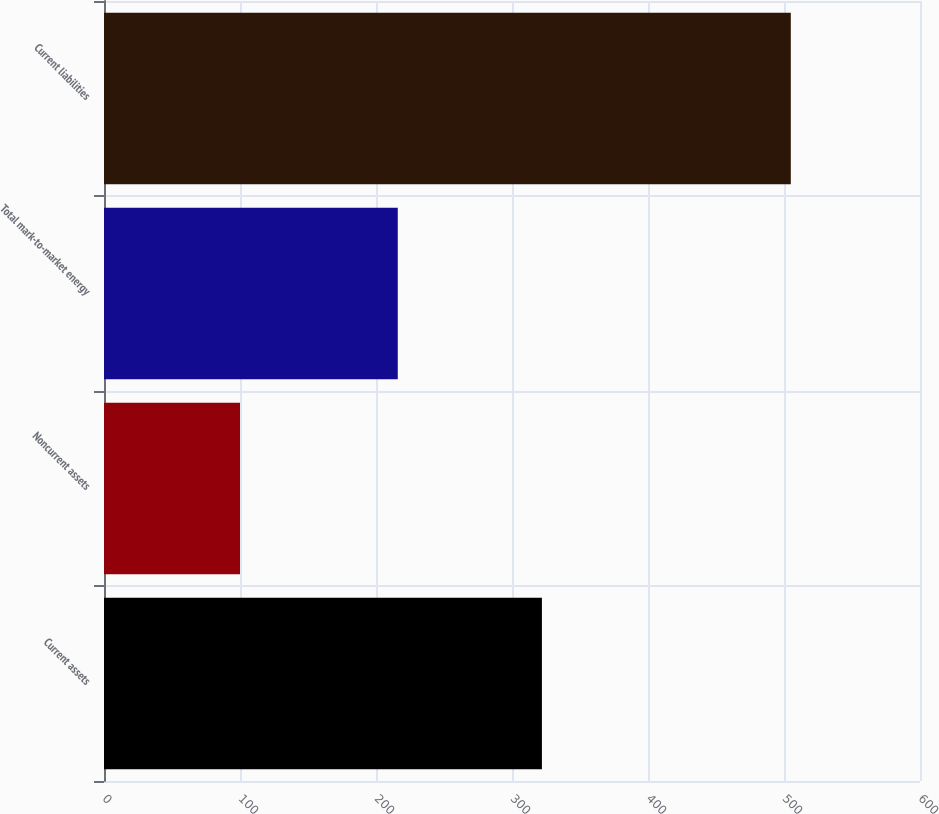<chart> <loc_0><loc_0><loc_500><loc_500><bar_chart><fcel>Current assets<fcel>Noncurrent assets<fcel>Total mark-to-market energy<fcel>Current liabilities<nl><fcel>322<fcel>100<fcel>216<fcel>505<nl></chart> 